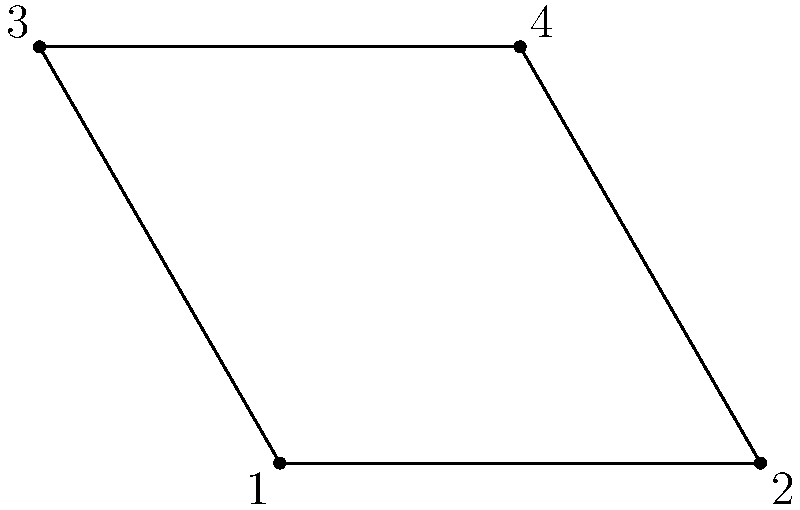Consider the rosette pattern commonly found in Scottish Reformist era architectural ornaments, represented by the diagram above. This pattern exhibits the symmetries of a dihedral group. How many elements are in the dihedral group that describes the symmetries of this rosette, and what is the order of rotation that generates this group? To determine the number of elements in the dihedral group and the order of rotation:

1. Count the number of vertices: The rosette has 4 vertices.

2. Identify rotational symmetries:
   - 0° (identity)
   - 90° clockwise
   - 180° clockwise
   - 270° clockwise
   There are 4 rotational symmetries.

3. Identify reflectional symmetries:
   - Reflection across AC
   - Reflection across BD
   - Reflection across the vertical line through the center
   - Reflection across the horizontal line through the center
   There are 4 reflectional symmetries.

4. Calculate total number of symmetries:
   Total = Rotations + Reflections = 4 + 4 = 8

5. Determine the order of rotation:
   The smallest non-identity rotation is 90°, which corresponds to a quarter-turn.
   This means the order of rotation is 4.

Therefore, the dihedral group describing this rosette's symmetries has 8 elements, and the order of rotation that generates this group is 4.
Answer: 8 elements; order 4 